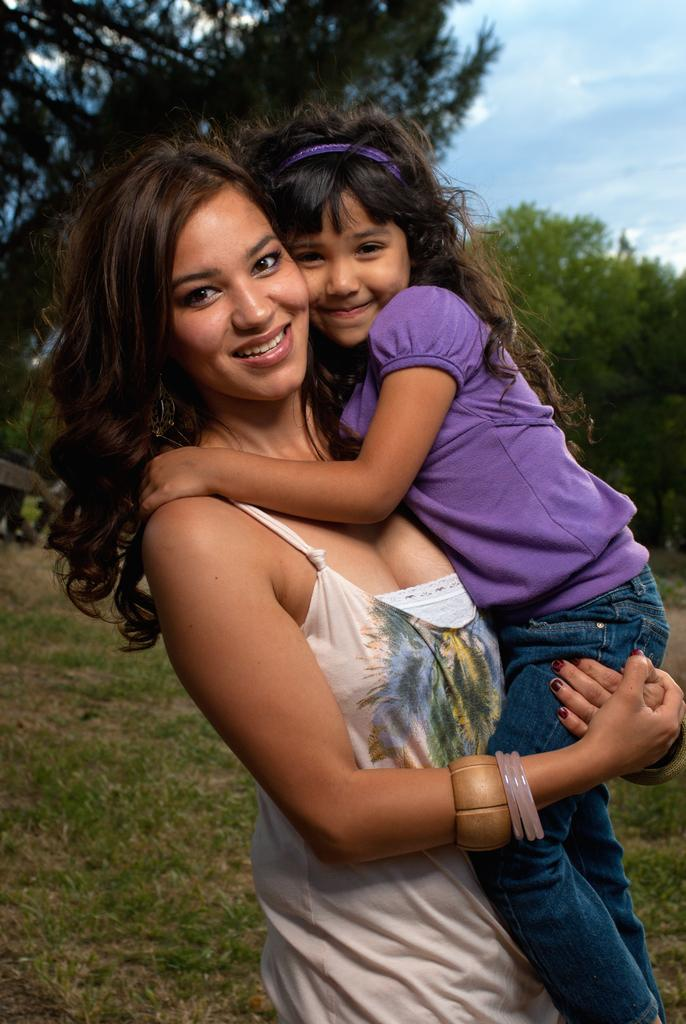What is happening in the foreground of the image? There is a woman standing in the foreground, and she is holding a baby. What can be seen in the background of the image? There are trees and the sky visible in the background. What type of terrain is present at the bottom of the image? There is grass at the bottom of the image. What type of education is the woman providing to the grass in the image? There is no indication in the image that the woman is providing any education to the grass, as the image focuses on the woman holding a baby. 